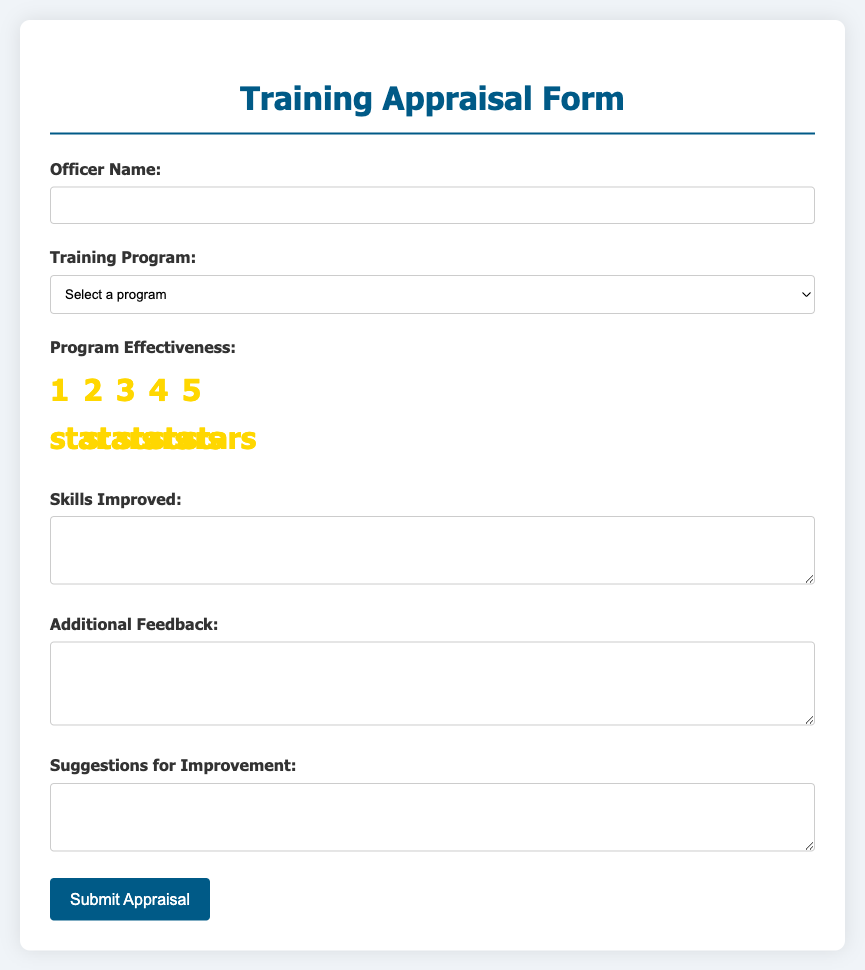What is the title of the document? The title of the document can be found in the header section.
Answer: Training Appraisal Form How many training program options are available? The number of program options can be counted in the dropdown menu of the document.
Answer: 4 What is the highest rating available in the program effectiveness section? The highest rating can be found among the star ratings provided.
Answer: 5 stars What field asks for additional feedback? The field that requests extra insights is specified in the form.
Answer: Additional Feedback What is the button label for submitting the appraisal? The label on the button indicates its function to submit the form.
Answer: Submit Appraisal What are the available training programs listed? The programs can be extracted from the dropdown options in the form.
Answer: Leadership Development, Crisis Negotiation, Advanced Investigations, Community Engagement What is required in the 'Skills Improved' section? The 'Skills Improved' section explicitly indicates what type of response is necessary.
Answer: A required response Which rating corresponds to 'Good'? The label next to the stars defines what "Good" is associated with.
Answer: 3 stars What type of questions are included in the feedback section? The nature of the queries in this section is specified for user responses.
Answer: Suggestions for Improvement 